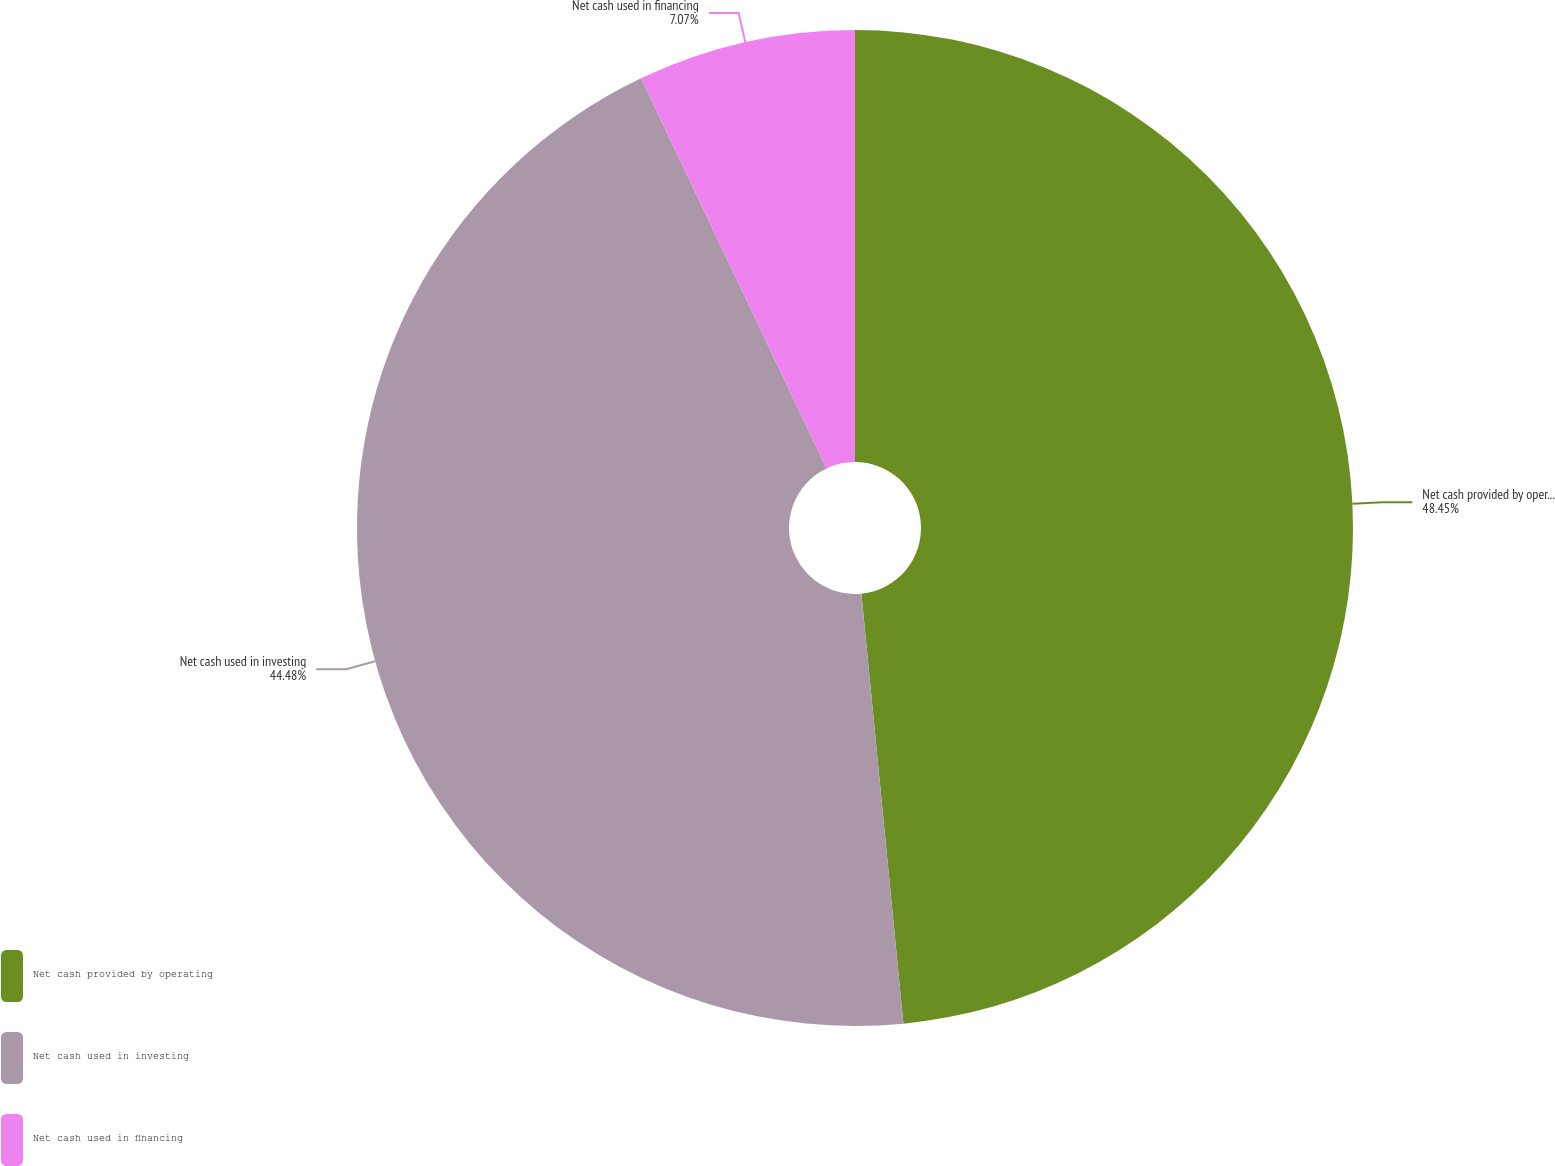Convert chart. <chart><loc_0><loc_0><loc_500><loc_500><pie_chart><fcel>Net cash provided by operating<fcel>Net cash used in investing<fcel>Net cash used in financing<nl><fcel>48.45%<fcel>44.48%<fcel>7.07%<nl></chart> 